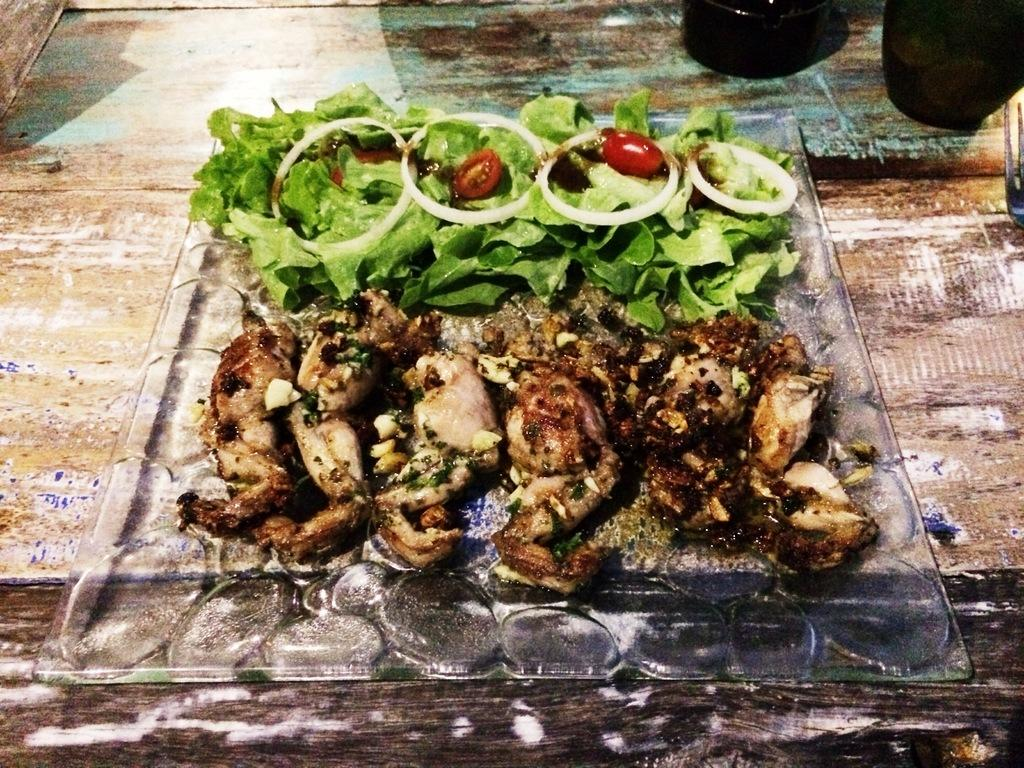What is present in the image related to food? There is food in the image. How is the food arranged or contained in the image? The food is in a plate. What type of cord is used to tie the oatmeal in the image? There is no oatmeal or cord present in the image. Are there any pets visible in the image? There is no mention of pets in the provided facts, so we cannot determine if any are present in the image. 